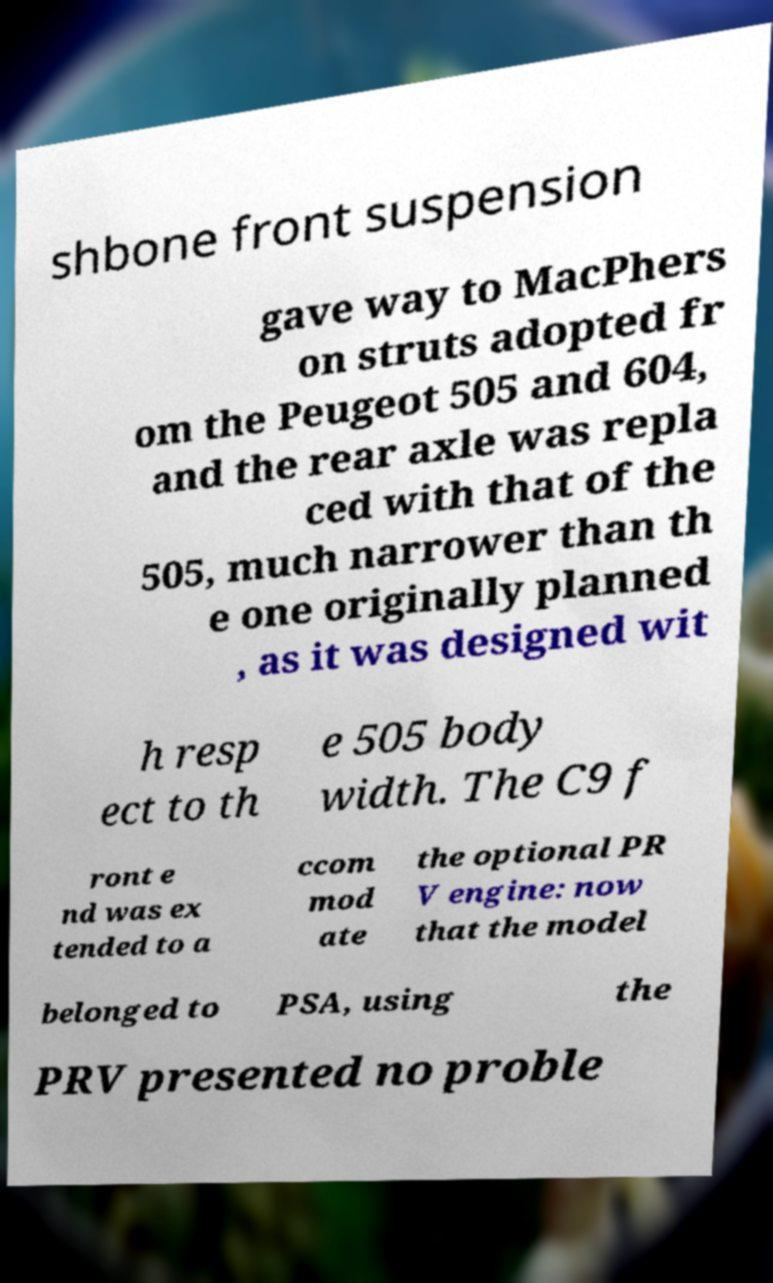There's text embedded in this image that I need extracted. Can you transcribe it verbatim? shbone front suspension gave way to MacPhers on struts adopted fr om the Peugeot 505 and 604, and the rear axle was repla ced with that of the 505, much narrower than th e one originally planned , as it was designed wit h resp ect to th e 505 body width. The C9 f ront e nd was ex tended to a ccom mod ate the optional PR V engine: now that the model belonged to PSA, using the PRV presented no proble 